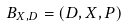Convert formula to latex. <formula><loc_0><loc_0><loc_500><loc_500>B _ { X , D } = ( D , X , P )</formula> 